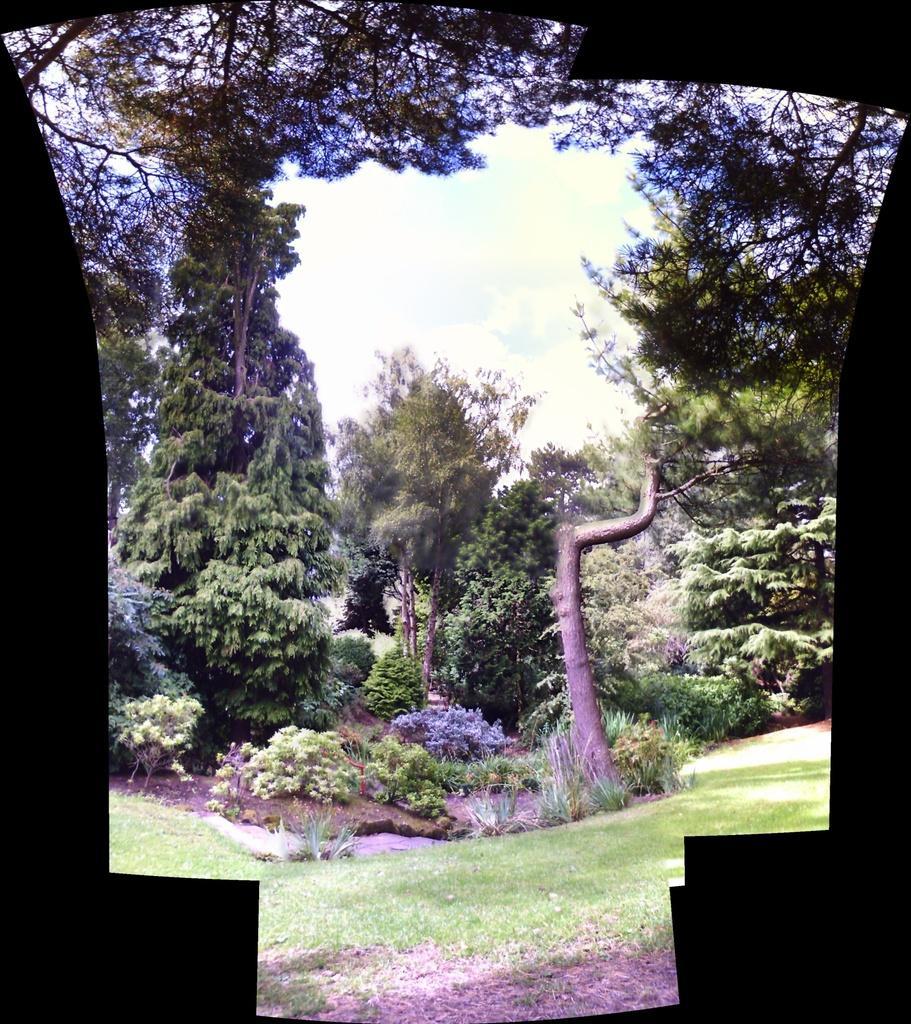In one or two sentences, can you explain what this image depicts? In this image I can see few trees and plants in green color. In the background the sky is in blue and white color. 